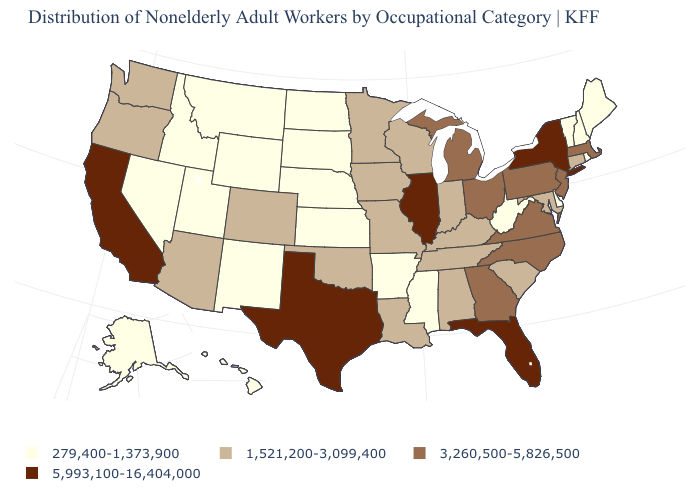Among the states that border Missouri , does Nebraska have the highest value?
Write a very short answer. No. Name the states that have a value in the range 1,521,200-3,099,400?
Keep it brief. Alabama, Arizona, Colorado, Connecticut, Indiana, Iowa, Kentucky, Louisiana, Maryland, Minnesota, Missouri, Oklahoma, Oregon, South Carolina, Tennessee, Washington, Wisconsin. What is the value of Wyoming?
Quick response, please. 279,400-1,373,900. What is the value of Wyoming?
Keep it brief. 279,400-1,373,900. Is the legend a continuous bar?
Keep it brief. No. Does the first symbol in the legend represent the smallest category?
Short answer required. Yes. What is the value of Maryland?
Be succinct. 1,521,200-3,099,400. Is the legend a continuous bar?
Concise answer only. No. Which states have the lowest value in the MidWest?
Answer briefly. Kansas, Nebraska, North Dakota, South Dakota. Does Connecticut have a higher value than New Hampshire?
Give a very brief answer. Yes. What is the lowest value in the USA?
Give a very brief answer. 279,400-1,373,900. Does Oregon have the same value as Arizona?
Be succinct. Yes. What is the value of Oklahoma?
Concise answer only. 1,521,200-3,099,400. Which states have the highest value in the USA?
Keep it brief. California, Florida, Illinois, New York, Texas. Name the states that have a value in the range 5,993,100-16,404,000?
Be succinct. California, Florida, Illinois, New York, Texas. 